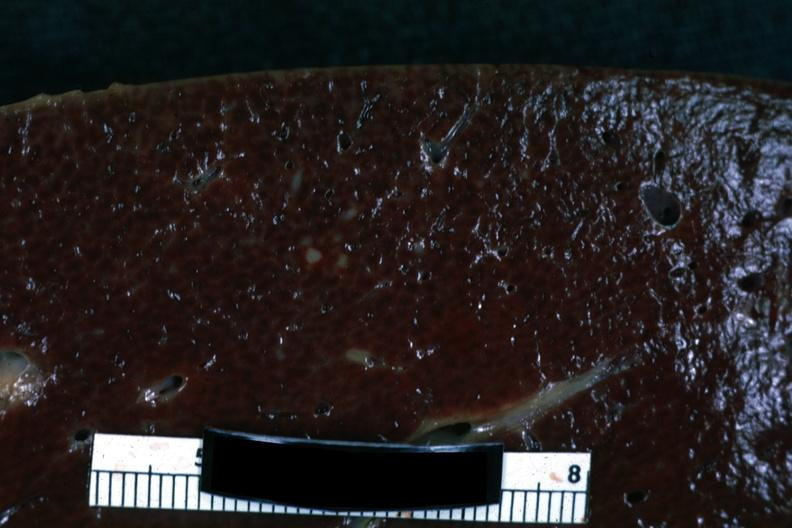s spleen present?
Answer the question using a single word or phrase. Yes 